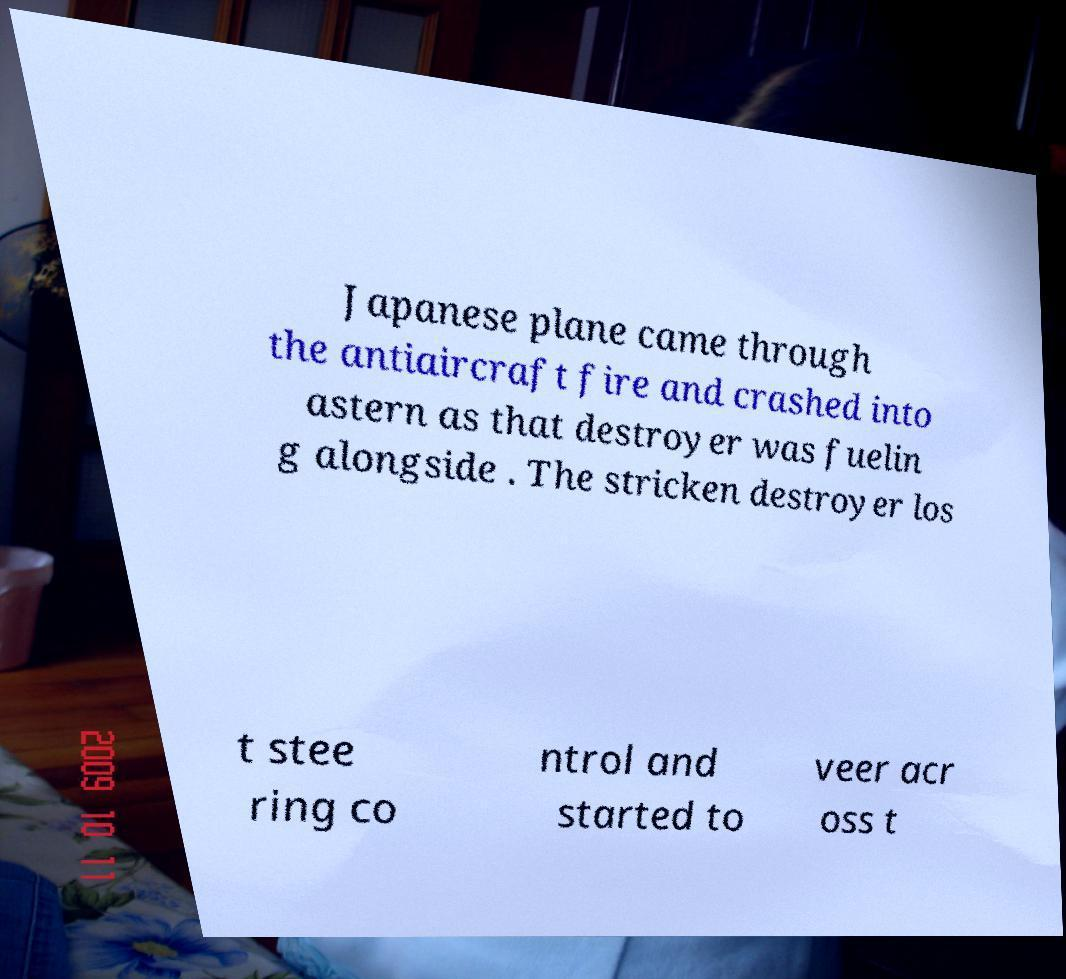There's text embedded in this image that I need extracted. Can you transcribe it verbatim? Japanese plane came through the antiaircraft fire and crashed into astern as that destroyer was fuelin g alongside . The stricken destroyer los t stee ring co ntrol and started to veer acr oss t 